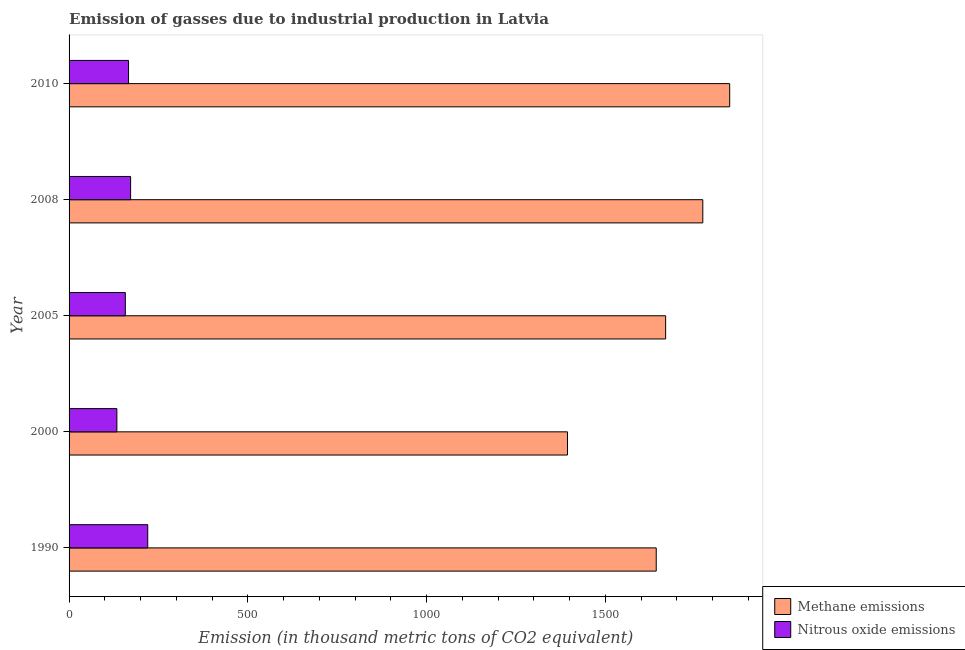How many different coloured bars are there?
Keep it short and to the point. 2. How many bars are there on the 4th tick from the bottom?
Offer a terse response. 2. What is the label of the 3rd group of bars from the top?
Give a very brief answer. 2005. What is the amount of methane emissions in 2005?
Offer a very short reply. 1668.3. Across all years, what is the maximum amount of methane emissions?
Make the answer very short. 1847.4. Across all years, what is the minimum amount of nitrous oxide emissions?
Give a very brief answer. 133.7. What is the total amount of methane emissions in the graph?
Offer a very short reply. 8323.7. What is the difference between the amount of nitrous oxide emissions in 2000 and that in 2010?
Your answer should be very brief. -32.6. What is the difference between the amount of methane emissions in 2008 and the amount of nitrous oxide emissions in 1990?
Provide a short and direct response. 1552.2. What is the average amount of methane emissions per year?
Your response must be concise. 1664.74. In the year 2008, what is the difference between the amount of nitrous oxide emissions and amount of methane emissions?
Your answer should be compact. -1600.1. In how many years, is the amount of methane emissions greater than 1600 thousand metric tons?
Provide a succinct answer. 4. What is the ratio of the amount of methane emissions in 2008 to that in 2010?
Provide a short and direct response. 0.96. What is the difference between the highest and the second highest amount of methane emissions?
Your answer should be compact. 75.2. What is the difference between the highest and the lowest amount of nitrous oxide emissions?
Provide a succinct answer. 86.3. In how many years, is the amount of methane emissions greater than the average amount of methane emissions taken over all years?
Provide a succinct answer. 3. What does the 2nd bar from the top in 1990 represents?
Offer a terse response. Methane emissions. What does the 2nd bar from the bottom in 2000 represents?
Ensure brevity in your answer.  Nitrous oxide emissions. How many years are there in the graph?
Your answer should be compact. 5. Does the graph contain grids?
Ensure brevity in your answer.  No. Where does the legend appear in the graph?
Ensure brevity in your answer.  Bottom right. What is the title of the graph?
Offer a terse response. Emission of gasses due to industrial production in Latvia. Does "Merchandise imports" appear as one of the legend labels in the graph?
Your response must be concise. No. What is the label or title of the X-axis?
Offer a terse response. Emission (in thousand metric tons of CO2 equivalent). What is the label or title of the Y-axis?
Keep it short and to the point. Year. What is the Emission (in thousand metric tons of CO2 equivalent) in Methane emissions in 1990?
Provide a short and direct response. 1642. What is the Emission (in thousand metric tons of CO2 equivalent) in Nitrous oxide emissions in 1990?
Offer a terse response. 220. What is the Emission (in thousand metric tons of CO2 equivalent) in Methane emissions in 2000?
Keep it short and to the point. 1393.8. What is the Emission (in thousand metric tons of CO2 equivalent) in Nitrous oxide emissions in 2000?
Offer a terse response. 133.7. What is the Emission (in thousand metric tons of CO2 equivalent) in Methane emissions in 2005?
Give a very brief answer. 1668.3. What is the Emission (in thousand metric tons of CO2 equivalent) in Nitrous oxide emissions in 2005?
Give a very brief answer. 157.3. What is the Emission (in thousand metric tons of CO2 equivalent) in Methane emissions in 2008?
Offer a terse response. 1772.2. What is the Emission (in thousand metric tons of CO2 equivalent) in Nitrous oxide emissions in 2008?
Make the answer very short. 172.1. What is the Emission (in thousand metric tons of CO2 equivalent) of Methane emissions in 2010?
Offer a very short reply. 1847.4. What is the Emission (in thousand metric tons of CO2 equivalent) of Nitrous oxide emissions in 2010?
Offer a terse response. 166.3. Across all years, what is the maximum Emission (in thousand metric tons of CO2 equivalent) of Methane emissions?
Make the answer very short. 1847.4. Across all years, what is the maximum Emission (in thousand metric tons of CO2 equivalent) in Nitrous oxide emissions?
Your response must be concise. 220. Across all years, what is the minimum Emission (in thousand metric tons of CO2 equivalent) in Methane emissions?
Offer a terse response. 1393.8. Across all years, what is the minimum Emission (in thousand metric tons of CO2 equivalent) in Nitrous oxide emissions?
Offer a very short reply. 133.7. What is the total Emission (in thousand metric tons of CO2 equivalent) of Methane emissions in the graph?
Provide a short and direct response. 8323.7. What is the total Emission (in thousand metric tons of CO2 equivalent) in Nitrous oxide emissions in the graph?
Make the answer very short. 849.4. What is the difference between the Emission (in thousand metric tons of CO2 equivalent) in Methane emissions in 1990 and that in 2000?
Your answer should be very brief. 248.2. What is the difference between the Emission (in thousand metric tons of CO2 equivalent) in Nitrous oxide emissions in 1990 and that in 2000?
Provide a short and direct response. 86.3. What is the difference between the Emission (in thousand metric tons of CO2 equivalent) of Methane emissions in 1990 and that in 2005?
Make the answer very short. -26.3. What is the difference between the Emission (in thousand metric tons of CO2 equivalent) of Nitrous oxide emissions in 1990 and that in 2005?
Keep it short and to the point. 62.7. What is the difference between the Emission (in thousand metric tons of CO2 equivalent) in Methane emissions in 1990 and that in 2008?
Ensure brevity in your answer.  -130.2. What is the difference between the Emission (in thousand metric tons of CO2 equivalent) in Nitrous oxide emissions in 1990 and that in 2008?
Offer a terse response. 47.9. What is the difference between the Emission (in thousand metric tons of CO2 equivalent) of Methane emissions in 1990 and that in 2010?
Ensure brevity in your answer.  -205.4. What is the difference between the Emission (in thousand metric tons of CO2 equivalent) of Nitrous oxide emissions in 1990 and that in 2010?
Ensure brevity in your answer.  53.7. What is the difference between the Emission (in thousand metric tons of CO2 equivalent) in Methane emissions in 2000 and that in 2005?
Your response must be concise. -274.5. What is the difference between the Emission (in thousand metric tons of CO2 equivalent) of Nitrous oxide emissions in 2000 and that in 2005?
Ensure brevity in your answer.  -23.6. What is the difference between the Emission (in thousand metric tons of CO2 equivalent) in Methane emissions in 2000 and that in 2008?
Provide a short and direct response. -378.4. What is the difference between the Emission (in thousand metric tons of CO2 equivalent) of Nitrous oxide emissions in 2000 and that in 2008?
Ensure brevity in your answer.  -38.4. What is the difference between the Emission (in thousand metric tons of CO2 equivalent) in Methane emissions in 2000 and that in 2010?
Ensure brevity in your answer.  -453.6. What is the difference between the Emission (in thousand metric tons of CO2 equivalent) in Nitrous oxide emissions in 2000 and that in 2010?
Give a very brief answer. -32.6. What is the difference between the Emission (in thousand metric tons of CO2 equivalent) of Methane emissions in 2005 and that in 2008?
Your answer should be very brief. -103.9. What is the difference between the Emission (in thousand metric tons of CO2 equivalent) of Nitrous oxide emissions in 2005 and that in 2008?
Your answer should be very brief. -14.8. What is the difference between the Emission (in thousand metric tons of CO2 equivalent) of Methane emissions in 2005 and that in 2010?
Your response must be concise. -179.1. What is the difference between the Emission (in thousand metric tons of CO2 equivalent) of Methane emissions in 2008 and that in 2010?
Keep it short and to the point. -75.2. What is the difference between the Emission (in thousand metric tons of CO2 equivalent) of Methane emissions in 1990 and the Emission (in thousand metric tons of CO2 equivalent) of Nitrous oxide emissions in 2000?
Keep it short and to the point. 1508.3. What is the difference between the Emission (in thousand metric tons of CO2 equivalent) in Methane emissions in 1990 and the Emission (in thousand metric tons of CO2 equivalent) in Nitrous oxide emissions in 2005?
Keep it short and to the point. 1484.7. What is the difference between the Emission (in thousand metric tons of CO2 equivalent) in Methane emissions in 1990 and the Emission (in thousand metric tons of CO2 equivalent) in Nitrous oxide emissions in 2008?
Offer a terse response. 1469.9. What is the difference between the Emission (in thousand metric tons of CO2 equivalent) of Methane emissions in 1990 and the Emission (in thousand metric tons of CO2 equivalent) of Nitrous oxide emissions in 2010?
Provide a short and direct response. 1475.7. What is the difference between the Emission (in thousand metric tons of CO2 equivalent) of Methane emissions in 2000 and the Emission (in thousand metric tons of CO2 equivalent) of Nitrous oxide emissions in 2005?
Make the answer very short. 1236.5. What is the difference between the Emission (in thousand metric tons of CO2 equivalent) in Methane emissions in 2000 and the Emission (in thousand metric tons of CO2 equivalent) in Nitrous oxide emissions in 2008?
Make the answer very short. 1221.7. What is the difference between the Emission (in thousand metric tons of CO2 equivalent) of Methane emissions in 2000 and the Emission (in thousand metric tons of CO2 equivalent) of Nitrous oxide emissions in 2010?
Provide a short and direct response. 1227.5. What is the difference between the Emission (in thousand metric tons of CO2 equivalent) in Methane emissions in 2005 and the Emission (in thousand metric tons of CO2 equivalent) in Nitrous oxide emissions in 2008?
Offer a very short reply. 1496.2. What is the difference between the Emission (in thousand metric tons of CO2 equivalent) in Methane emissions in 2005 and the Emission (in thousand metric tons of CO2 equivalent) in Nitrous oxide emissions in 2010?
Your answer should be compact. 1502. What is the difference between the Emission (in thousand metric tons of CO2 equivalent) of Methane emissions in 2008 and the Emission (in thousand metric tons of CO2 equivalent) of Nitrous oxide emissions in 2010?
Offer a very short reply. 1605.9. What is the average Emission (in thousand metric tons of CO2 equivalent) of Methane emissions per year?
Your answer should be compact. 1664.74. What is the average Emission (in thousand metric tons of CO2 equivalent) in Nitrous oxide emissions per year?
Give a very brief answer. 169.88. In the year 1990, what is the difference between the Emission (in thousand metric tons of CO2 equivalent) of Methane emissions and Emission (in thousand metric tons of CO2 equivalent) of Nitrous oxide emissions?
Offer a very short reply. 1422. In the year 2000, what is the difference between the Emission (in thousand metric tons of CO2 equivalent) of Methane emissions and Emission (in thousand metric tons of CO2 equivalent) of Nitrous oxide emissions?
Provide a short and direct response. 1260.1. In the year 2005, what is the difference between the Emission (in thousand metric tons of CO2 equivalent) of Methane emissions and Emission (in thousand metric tons of CO2 equivalent) of Nitrous oxide emissions?
Your answer should be compact. 1511. In the year 2008, what is the difference between the Emission (in thousand metric tons of CO2 equivalent) of Methane emissions and Emission (in thousand metric tons of CO2 equivalent) of Nitrous oxide emissions?
Make the answer very short. 1600.1. In the year 2010, what is the difference between the Emission (in thousand metric tons of CO2 equivalent) of Methane emissions and Emission (in thousand metric tons of CO2 equivalent) of Nitrous oxide emissions?
Your response must be concise. 1681.1. What is the ratio of the Emission (in thousand metric tons of CO2 equivalent) in Methane emissions in 1990 to that in 2000?
Ensure brevity in your answer.  1.18. What is the ratio of the Emission (in thousand metric tons of CO2 equivalent) in Nitrous oxide emissions in 1990 to that in 2000?
Make the answer very short. 1.65. What is the ratio of the Emission (in thousand metric tons of CO2 equivalent) in Methane emissions in 1990 to that in 2005?
Ensure brevity in your answer.  0.98. What is the ratio of the Emission (in thousand metric tons of CO2 equivalent) in Nitrous oxide emissions in 1990 to that in 2005?
Provide a short and direct response. 1.4. What is the ratio of the Emission (in thousand metric tons of CO2 equivalent) in Methane emissions in 1990 to that in 2008?
Your answer should be very brief. 0.93. What is the ratio of the Emission (in thousand metric tons of CO2 equivalent) in Nitrous oxide emissions in 1990 to that in 2008?
Your answer should be very brief. 1.28. What is the ratio of the Emission (in thousand metric tons of CO2 equivalent) of Methane emissions in 1990 to that in 2010?
Your answer should be compact. 0.89. What is the ratio of the Emission (in thousand metric tons of CO2 equivalent) in Nitrous oxide emissions in 1990 to that in 2010?
Offer a very short reply. 1.32. What is the ratio of the Emission (in thousand metric tons of CO2 equivalent) of Methane emissions in 2000 to that in 2005?
Ensure brevity in your answer.  0.84. What is the ratio of the Emission (in thousand metric tons of CO2 equivalent) in Methane emissions in 2000 to that in 2008?
Give a very brief answer. 0.79. What is the ratio of the Emission (in thousand metric tons of CO2 equivalent) in Nitrous oxide emissions in 2000 to that in 2008?
Your response must be concise. 0.78. What is the ratio of the Emission (in thousand metric tons of CO2 equivalent) in Methane emissions in 2000 to that in 2010?
Your answer should be compact. 0.75. What is the ratio of the Emission (in thousand metric tons of CO2 equivalent) of Nitrous oxide emissions in 2000 to that in 2010?
Keep it short and to the point. 0.8. What is the ratio of the Emission (in thousand metric tons of CO2 equivalent) of Methane emissions in 2005 to that in 2008?
Offer a very short reply. 0.94. What is the ratio of the Emission (in thousand metric tons of CO2 equivalent) of Nitrous oxide emissions in 2005 to that in 2008?
Offer a very short reply. 0.91. What is the ratio of the Emission (in thousand metric tons of CO2 equivalent) in Methane emissions in 2005 to that in 2010?
Provide a short and direct response. 0.9. What is the ratio of the Emission (in thousand metric tons of CO2 equivalent) of Nitrous oxide emissions in 2005 to that in 2010?
Make the answer very short. 0.95. What is the ratio of the Emission (in thousand metric tons of CO2 equivalent) of Methane emissions in 2008 to that in 2010?
Offer a terse response. 0.96. What is the ratio of the Emission (in thousand metric tons of CO2 equivalent) of Nitrous oxide emissions in 2008 to that in 2010?
Offer a very short reply. 1.03. What is the difference between the highest and the second highest Emission (in thousand metric tons of CO2 equivalent) in Methane emissions?
Offer a terse response. 75.2. What is the difference between the highest and the second highest Emission (in thousand metric tons of CO2 equivalent) of Nitrous oxide emissions?
Your response must be concise. 47.9. What is the difference between the highest and the lowest Emission (in thousand metric tons of CO2 equivalent) in Methane emissions?
Ensure brevity in your answer.  453.6. What is the difference between the highest and the lowest Emission (in thousand metric tons of CO2 equivalent) in Nitrous oxide emissions?
Give a very brief answer. 86.3. 